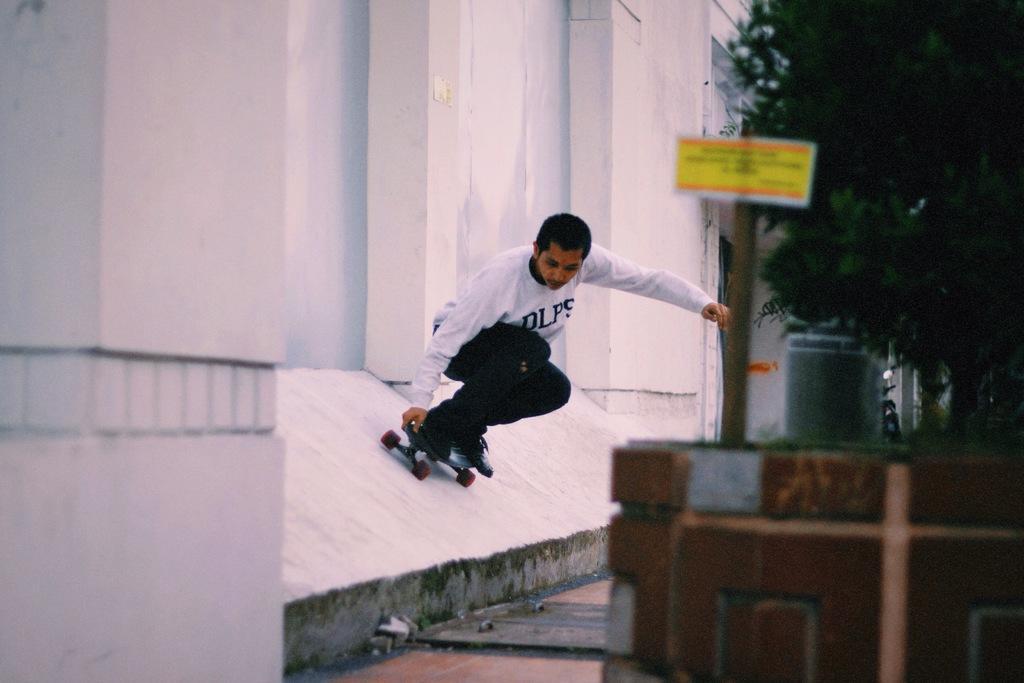Please provide a concise description of this image. In the picture we can see a man skating on the wall and beside him we can see the tree and a pole with a board to it. 